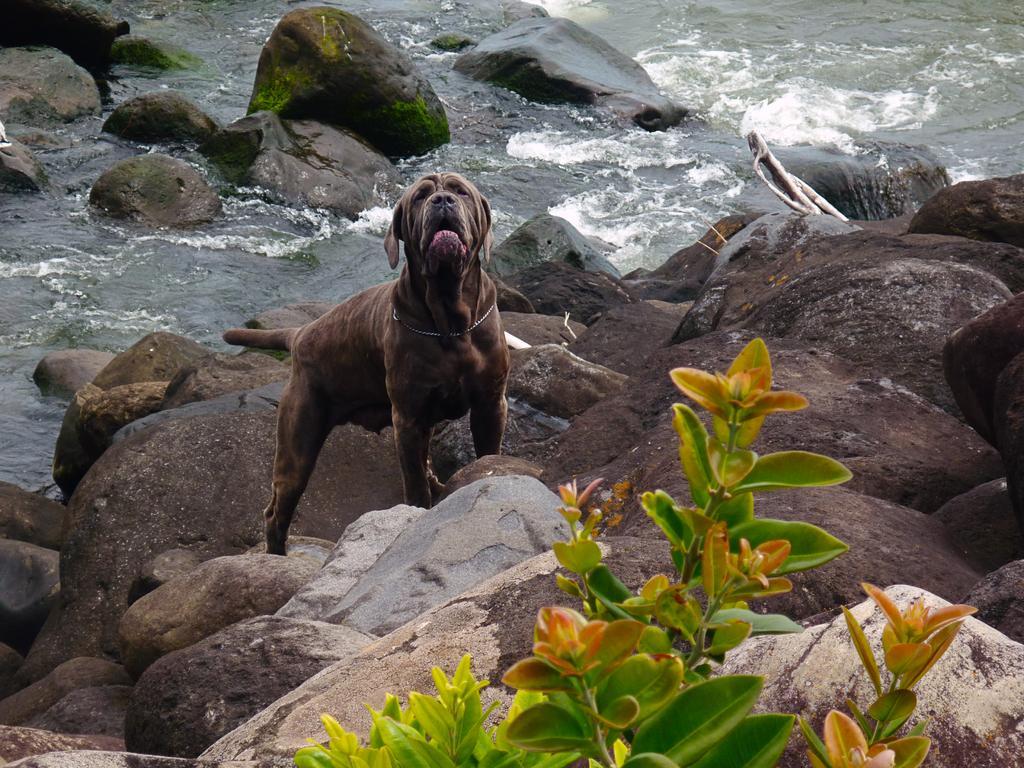Please provide a concise description of this image. This image consists of a dog in brown color. At the bottom, there are rocks along with a plant. In the background, we can see the water flowing. 